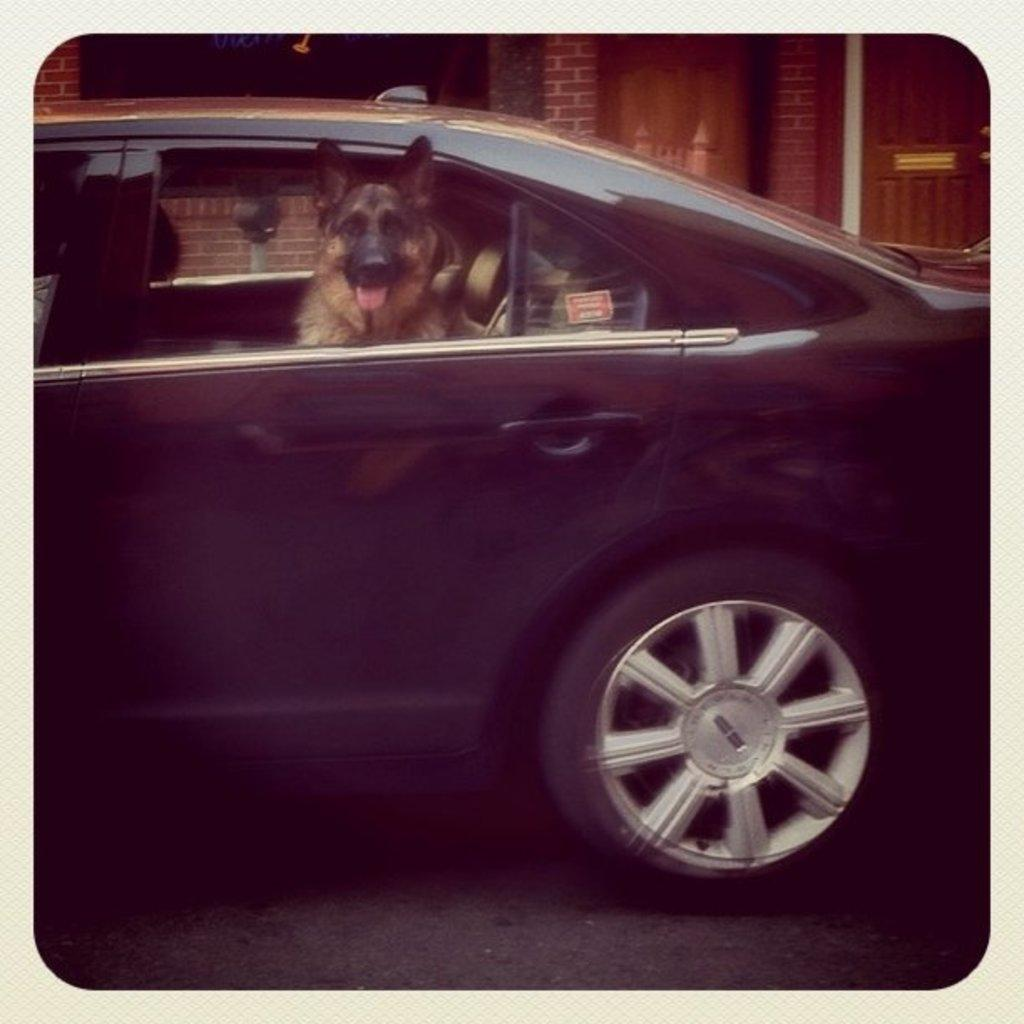What animal is present in the image? There is a dog in the image. Where is the dog located in the image? The dog is sitting in a car. What can be seen in the background of the image? There is a building visible in the background of the image. What type of doll is the dog playing with in the image? There is no doll present in the image; the dog is sitting in a car. 